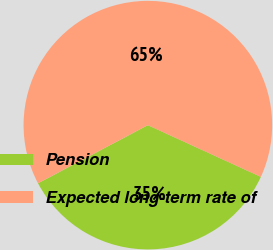<chart> <loc_0><loc_0><loc_500><loc_500><pie_chart><fcel>Pension<fcel>Expected long-term rate of<nl><fcel>35.42%<fcel>64.58%<nl></chart> 